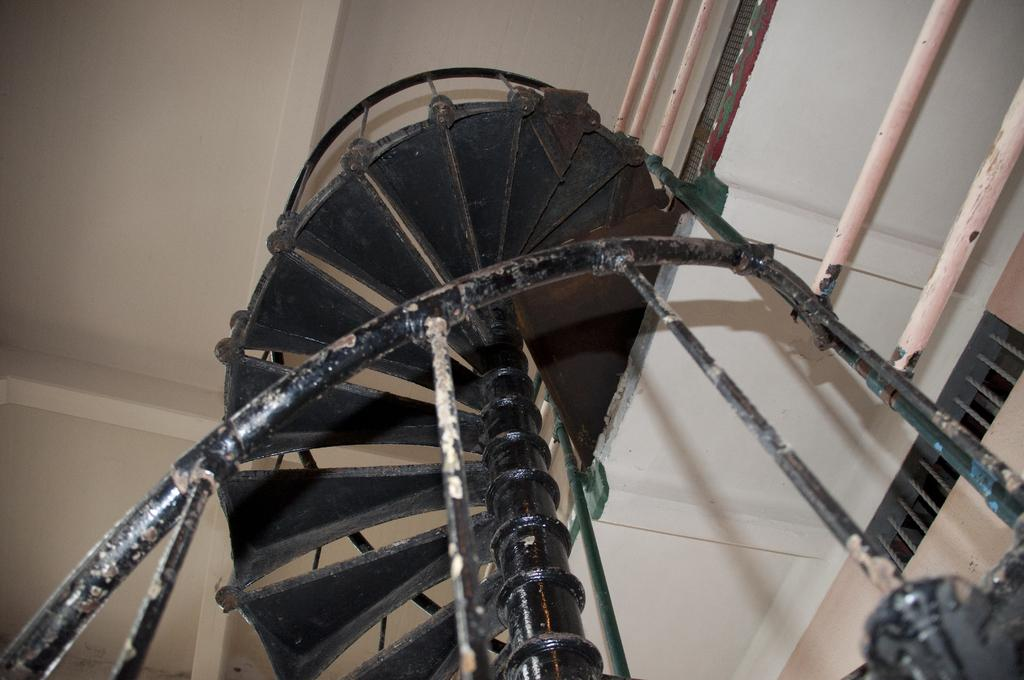What type of structure can be seen in the image? There are stairs and a rooftop visible in the image. Can you describe the stairs in the image? The image shows a set of stairs, but specific details about the stairs cannot be determined from the provided facts. What is located above the stairs in the image? The rooftop is located above the stairs in the image. Can you tell me how many goldfish are swimming in the rooftop pool in the image? There is no pool or goldfish present in the image; it only features stairs and a rooftop. What type of fang is visible on the stairs in the image? There is no fang present in the image; it only features stairs and a rooftop. 